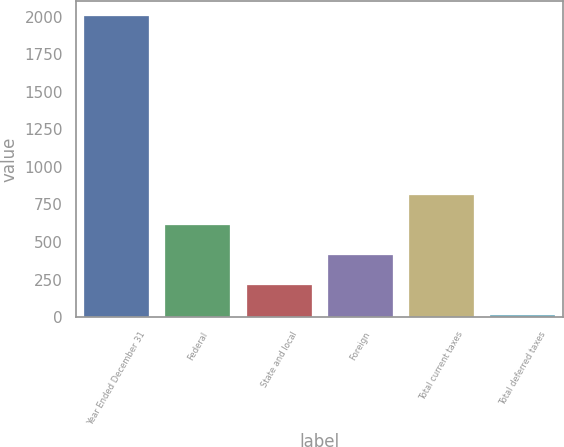Convert chart to OTSL. <chart><loc_0><loc_0><loc_500><loc_500><bar_chart><fcel>Year Ended December 31<fcel>Federal<fcel>State and local<fcel>Foreign<fcel>Total current taxes<fcel>Total deferred taxes<nl><fcel>2006<fcel>610.83<fcel>212.21<fcel>411.52<fcel>810.14<fcel>12.9<nl></chart> 